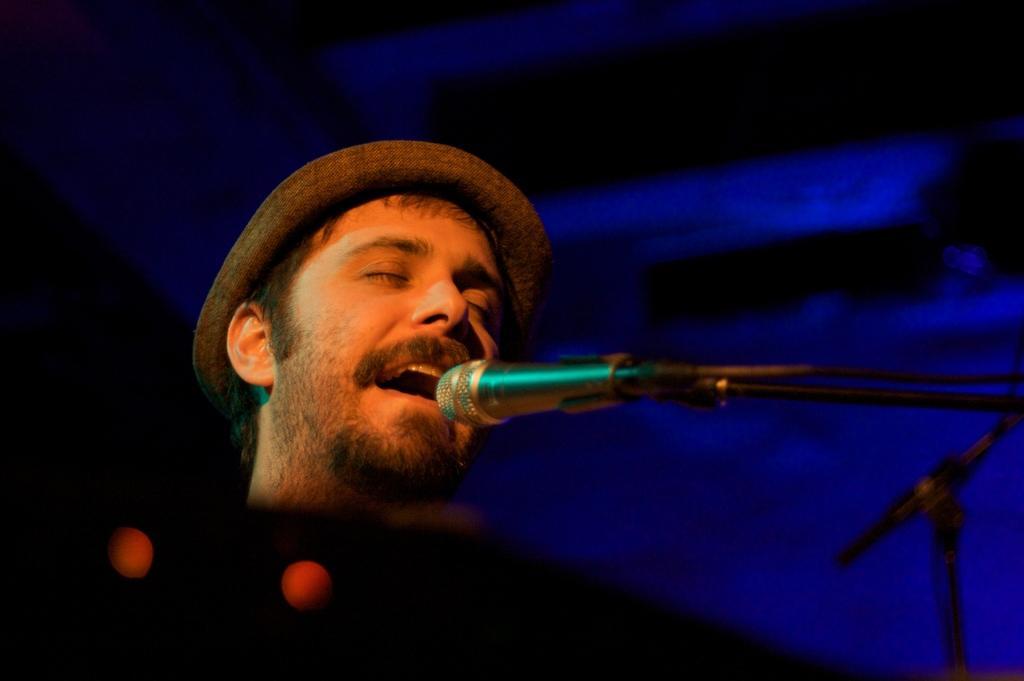Can you describe this image briefly? There is a person wearing a cap and singing in front of a mic which is attached to the stand. And the background is dark in color. 